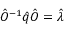<formula> <loc_0><loc_0><loc_500><loc_500>\hat { O } ^ { - 1 } \hat { q } \hat { O } = \hat { \lambda }</formula> 